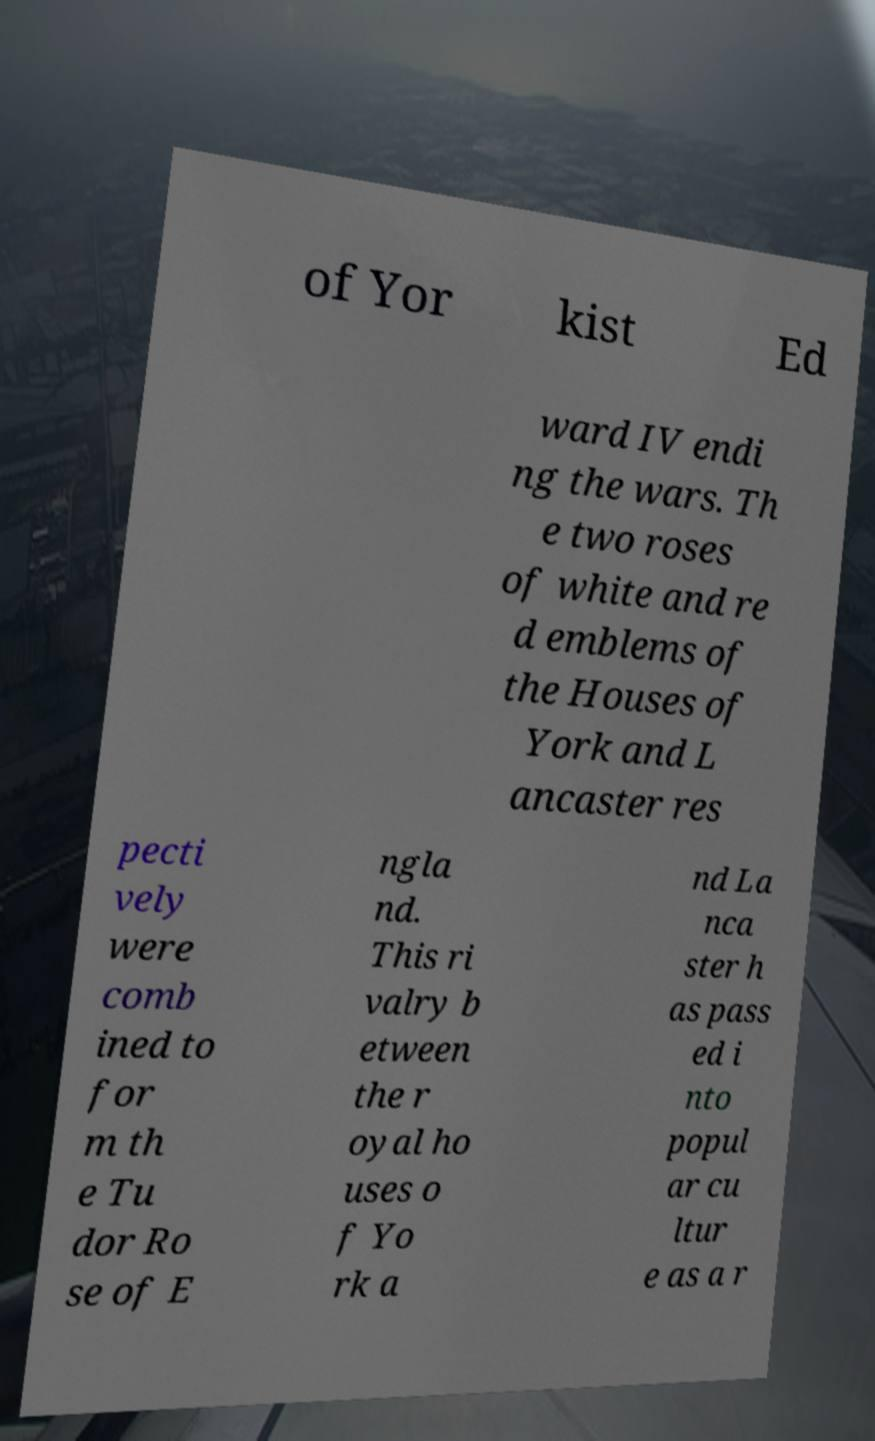What messages or text are displayed in this image? I need them in a readable, typed format. of Yor kist Ed ward IV endi ng the wars. Th e two roses of white and re d emblems of the Houses of York and L ancaster res pecti vely were comb ined to for m th e Tu dor Ro se of E ngla nd. This ri valry b etween the r oyal ho uses o f Yo rk a nd La nca ster h as pass ed i nto popul ar cu ltur e as a r 